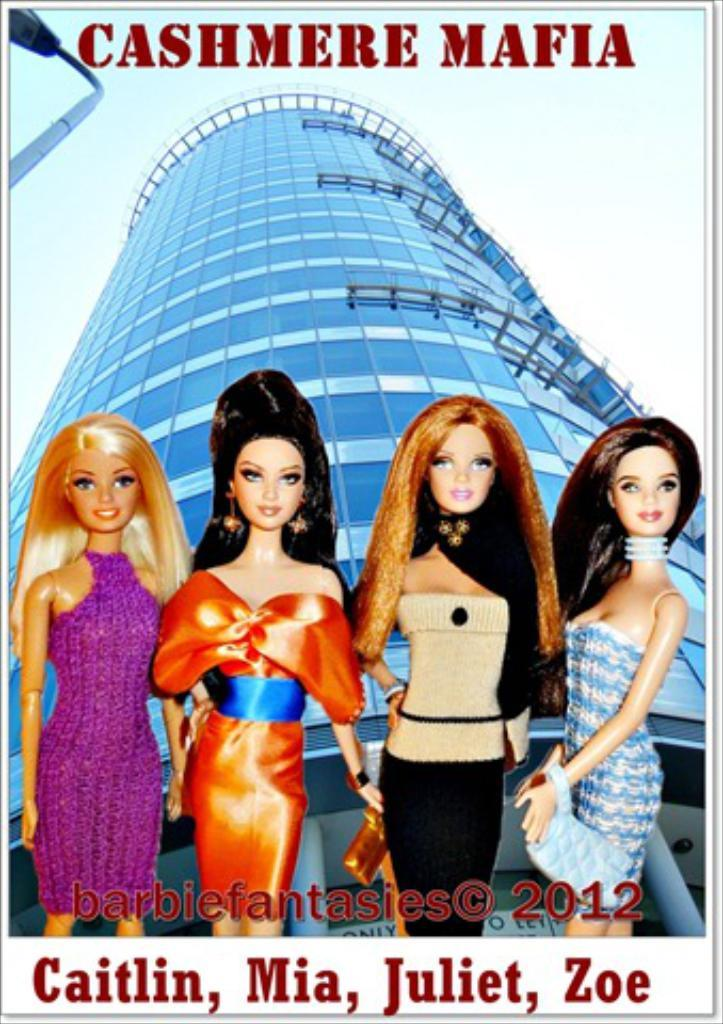What is featured in the image? There is a poster in the image. What is depicted on the poster? The poster contains four girls. What can be seen in the background of the poster? There is a building visible in the background of the poster. Are there any words or phrases on the poster? Yes, there are words or phrases written around the poster. What type of poison is being used by the cart in the image? There is no cart or poison present in the image. Can you describe the grandfather's role in the image? There is no grandfather present in the image. 